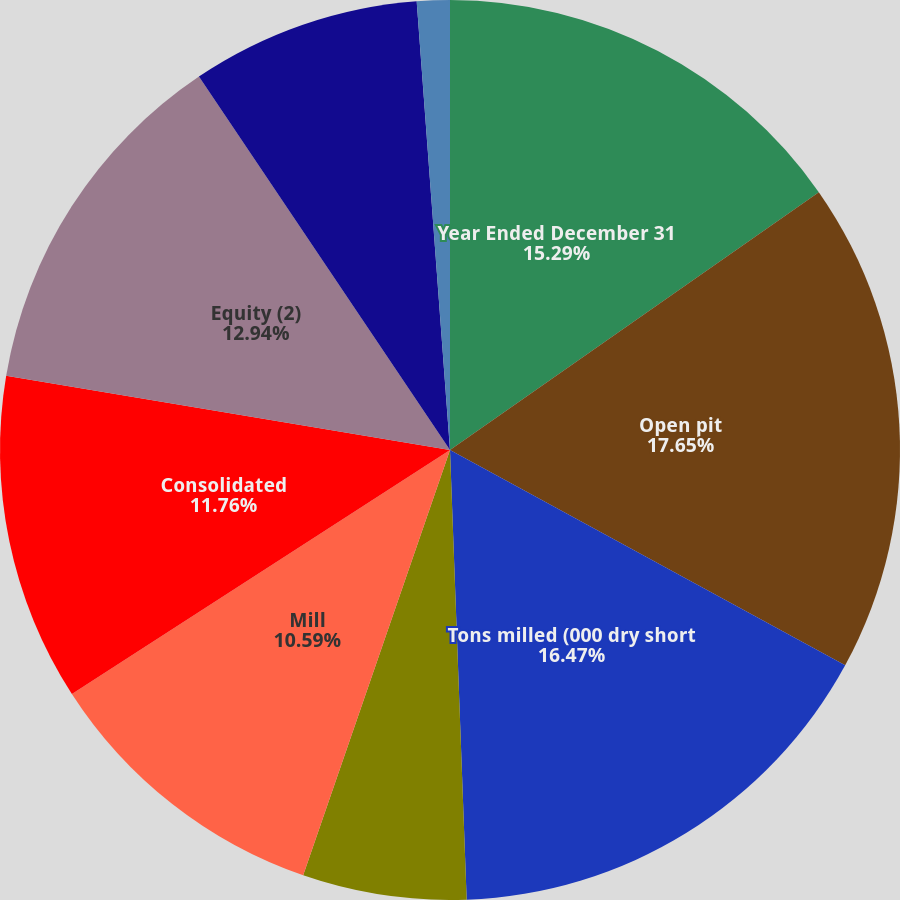Convert chart. <chart><loc_0><loc_0><loc_500><loc_500><pie_chart><fcel>Year Ended December 31<fcel>Open pit<fcel>Tons milled (000 dry short<fcel>Average ore grade (oz/ton)<fcel>Average mill recovery rate<fcel>Mill<fcel>Consolidated<fcel>Equity (2)<fcel>Direct mining and production<fcel>By-product credits<nl><fcel>15.29%<fcel>17.65%<fcel>16.47%<fcel>0.0%<fcel>5.88%<fcel>10.59%<fcel>11.76%<fcel>12.94%<fcel>8.24%<fcel>1.18%<nl></chart> 